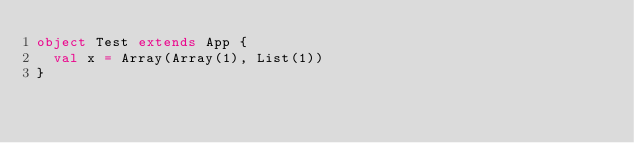Convert code to text. <code><loc_0><loc_0><loc_500><loc_500><_Scala_>object Test extends App {
  val x = Array(Array(1), List(1))
}
</code> 